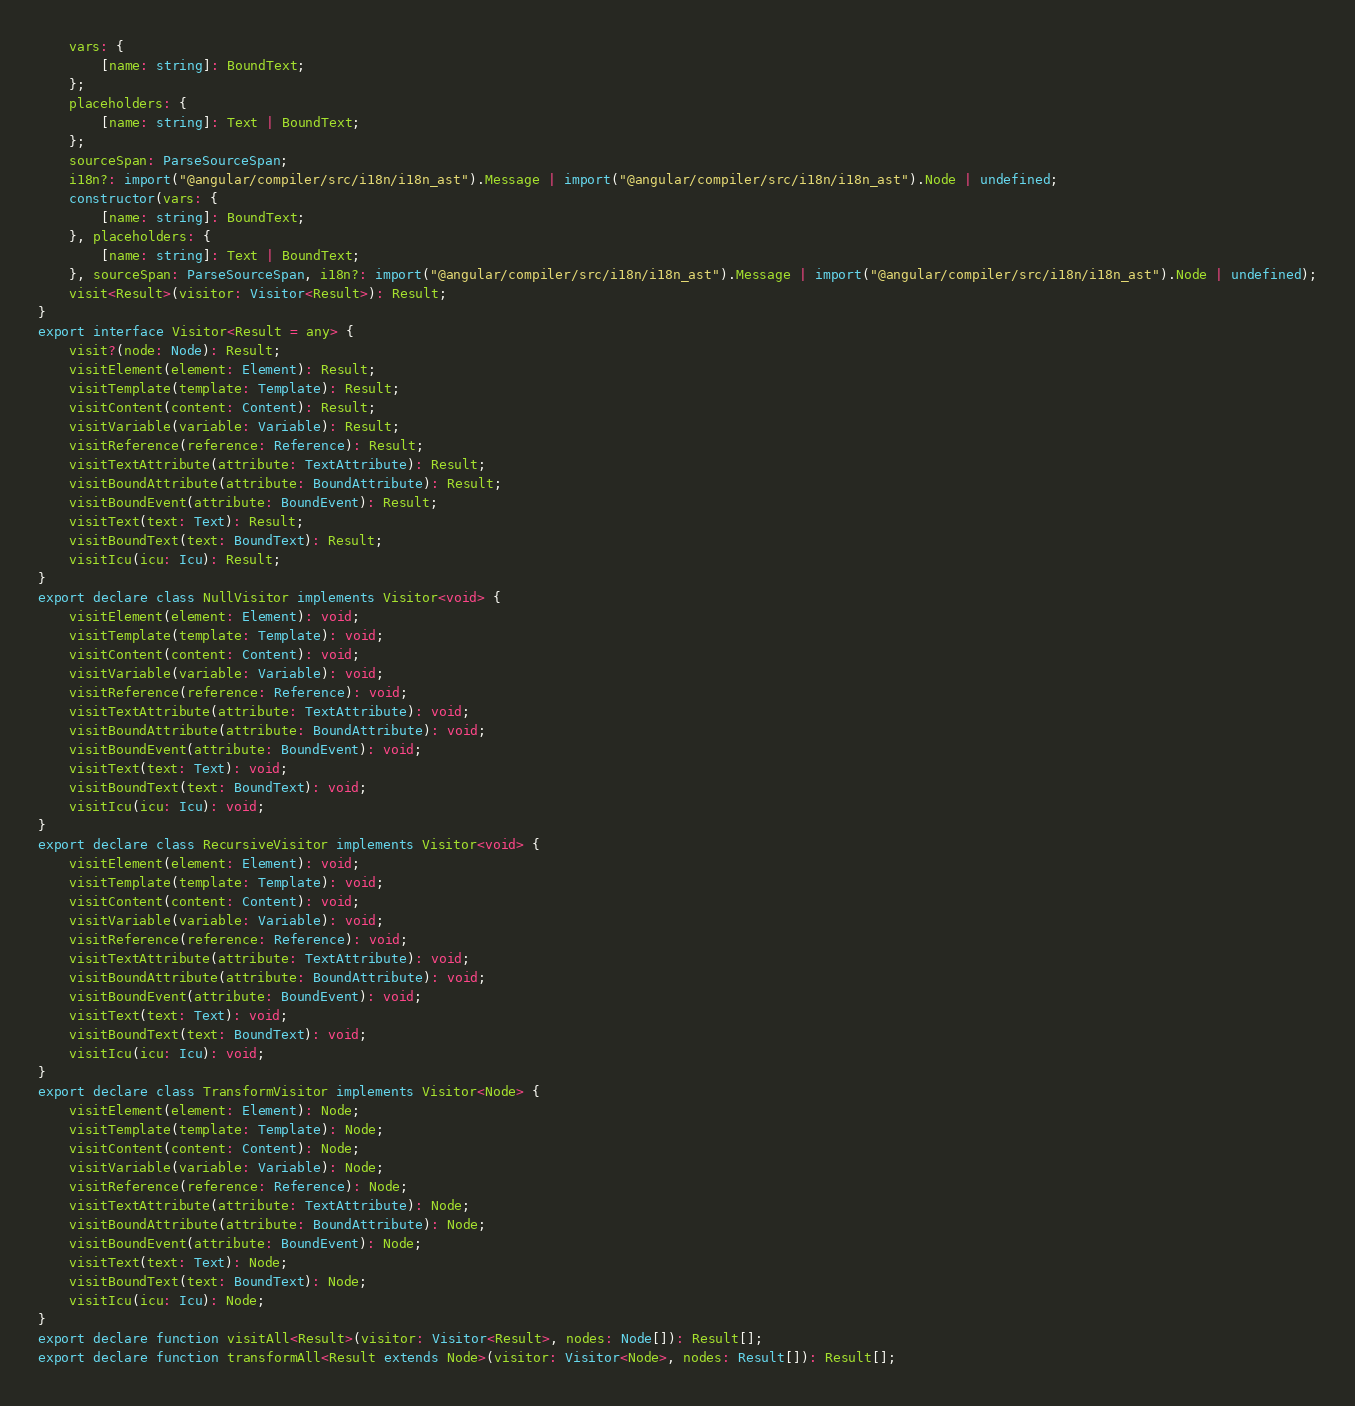Convert code to text. <code><loc_0><loc_0><loc_500><loc_500><_TypeScript_>    vars: {
        [name: string]: BoundText;
    };
    placeholders: {
        [name: string]: Text | BoundText;
    };
    sourceSpan: ParseSourceSpan;
    i18n?: import("@angular/compiler/src/i18n/i18n_ast").Message | import("@angular/compiler/src/i18n/i18n_ast").Node | undefined;
    constructor(vars: {
        [name: string]: BoundText;
    }, placeholders: {
        [name: string]: Text | BoundText;
    }, sourceSpan: ParseSourceSpan, i18n?: import("@angular/compiler/src/i18n/i18n_ast").Message | import("@angular/compiler/src/i18n/i18n_ast").Node | undefined);
    visit<Result>(visitor: Visitor<Result>): Result;
}
export interface Visitor<Result = any> {
    visit?(node: Node): Result;
    visitElement(element: Element): Result;
    visitTemplate(template: Template): Result;
    visitContent(content: Content): Result;
    visitVariable(variable: Variable): Result;
    visitReference(reference: Reference): Result;
    visitTextAttribute(attribute: TextAttribute): Result;
    visitBoundAttribute(attribute: BoundAttribute): Result;
    visitBoundEvent(attribute: BoundEvent): Result;
    visitText(text: Text): Result;
    visitBoundText(text: BoundText): Result;
    visitIcu(icu: Icu): Result;
}
export declare class NullVisitor implements Visitor<void> {
    visitElement(element: Element): void;
    visitTemplate(template: Template): void;
    visitContent(content: Content): void;
    visitVariable(variable: Variable): void;
    visitReference(reference: Reference): void;
    visitTextAttribute(attribute: TextAttribute): void;
    visitBoundAttribute(attribute: BoundAttribute): void;
    visitBoundEvent(attribute: BoundEvent): void;
    visitText(text: Text): void;
    visitBoundText(text: BoundText): void;
    visitIcu(icu: Icu): void;
}
export declare class RecursiveVisitor implements Visitor<void> {
    visitElement(element: Element): void;
    visitTemplate(template: Template): void;
    visitContent(content: Content): void;
    visitVariable(variable: Variable): void;
    visitReference(reference: Reference): void;
    visitTextAttribute(attribute: TextAttribute): void;
    visitBoundAttribute(attribute: BoundAttribute): void;
    visitBoundEvent(attribute: BoundEvent): void;
    visitText(text: Text): void;
    visitBoundText(text: BoundText): void;
    visitIcu(icu: Icu): void;
}
export declare class TransformVisitor implements Visitor<Node> {
    visitElement(element: Element): Node;
    visitTemplate(template: Template): Node;
    visitContent(content: Content): Node;
    visitVariable(variable: Variable): Node;
    visitReference(reference: Reference): Node;
    visitTextAttribute(attribute: TextAttribute): Node;
    visitBoundAttribute(attribute: BoundAttribute): Node;
    visitBoundEvent(attribute: BoundEvent): Node;
    visitText(text: Text): Node;
    visitBoundText(text: BoundText): Node;
    visitIcu(icu: Icu): Node;
}
export declare function visitAll<Result>(visitor: Visitor<Result>, nodes: Node[]): Result[];
export declare function transformAll<Result extends Node>(visitor: Visitor<Node>, nodes: Result[]): Result[];
</code> 